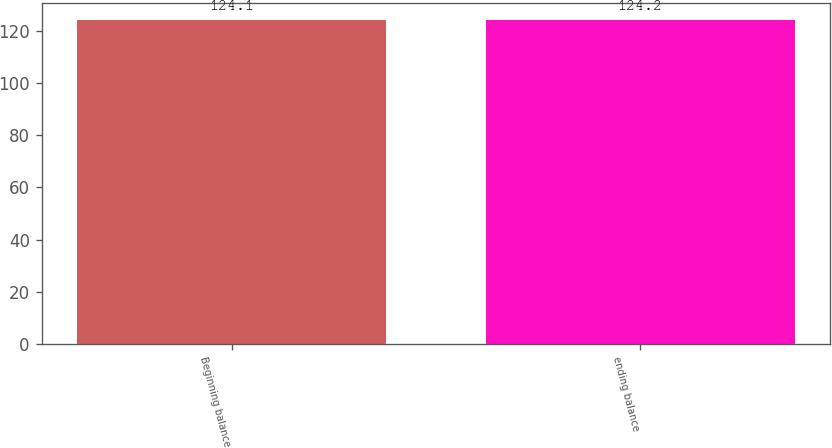Convert chart. <chart><loc_0><loc_0><loc_500><loc_500><bar_chart><fcel>Beginning balance<fcel>ending balance<nl><fcel>124.1<fcel>124.2<nl></chart> 